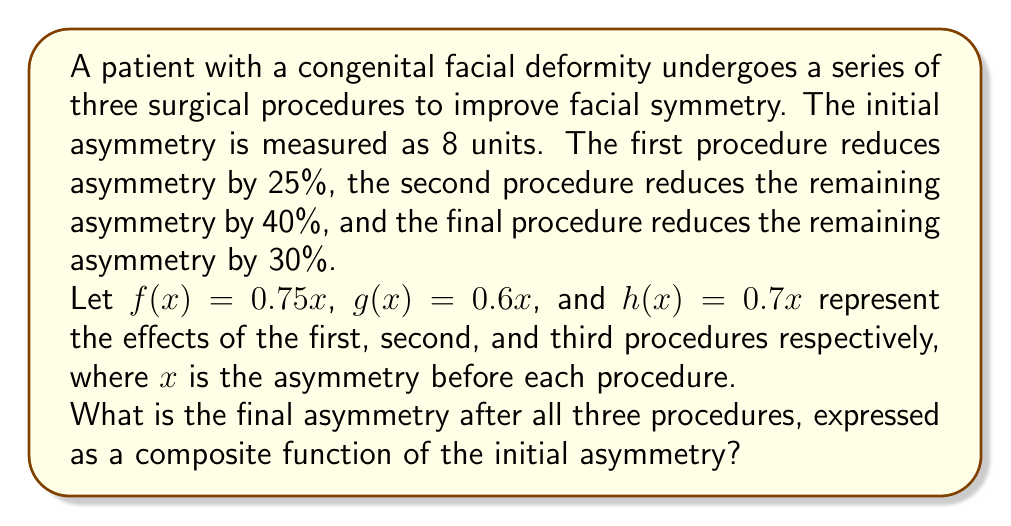Help me with this question. Let's approach this step-by-step:

1) We start with an initial asymmetry of 8 units.

2) The composite function will be applied in the order of the surgeries: $h(g(f(x)))$

3) Let's break it down:
   
   a) First procedure: $f(x) = 0.75x$
      This reduces asymmetry by 25%, leaving 75% of the original asymmetry.
   
   b) Second procedure: $g(x) = 0.6x$
      This reduces the remaining asymmetry by 40%, leaving 60% of what was left.
   
   c) Third procedure: $h(x) = 0.7x$
      This reduces the remaining asymmetry by 30%, leaving 70% of what was left.

4) Now, let's compose these functions:
   
   $h(g(f(x))) = h(g(0.75x))$
                $= h(0.6(0.75x))$
                $= 0.7(0.6(0.75x))$
                $= 0.7 \cdot 0.6 \cdot 0.75x$
                $= 0.315x$

5) Therefore, the composite function that represents the final asymmetry after all three procedures is $0.315x$.

6) To find the final asymmetry, we apply this to the initial asymmetry of 8:
   
   Final asymmetry $= 0.315 \cdot 8 = 2.52$ units
Answer: $0.315x$ 